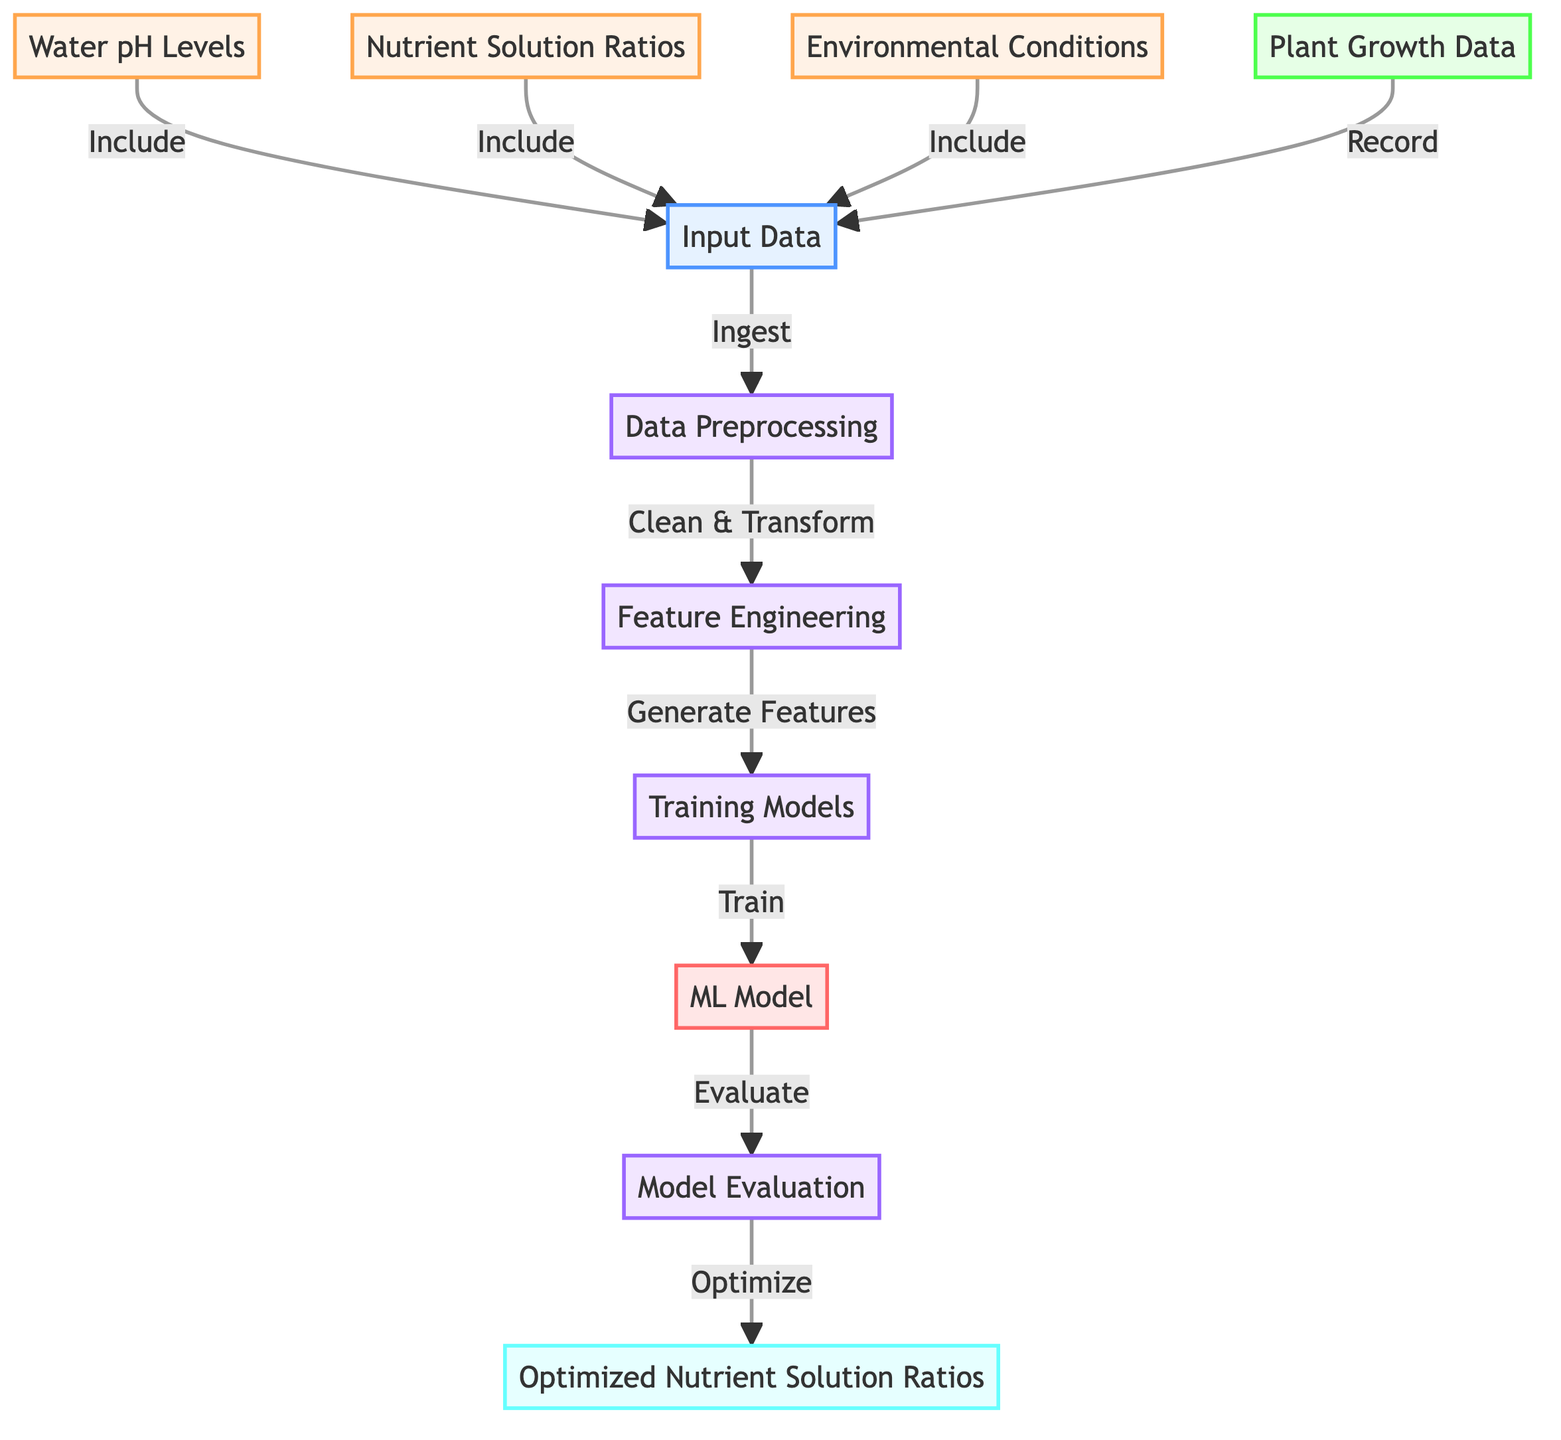What are the main factors included in the input data? According to the diagram, the main factors included in the input data are water pH levels, nutrient solution ratios, and environmental conditions. These nodes are connected with an "Include" relation to the input data node, indicating they are part of the data set being processed.
Answer: Water pH levels, nutrient solution ratios, environmental conditions How many processes are there in the diagram? The diagram contains four processes: data preprocessing, feature engineering, training models, and model evaluation. Each is distinctly marked as a process with specific nodes that reflect actions taken during the machine learning workflow.
Answer: Four What is the final output of the diagram? The final output of the diagram is the optimized nutrient solution ratios, which results from the model evaluation stage that optimizes the inputs based on the trained machine learning model. This node is clearly labeled as the output in the flowchart.
Answer: Optimized nutrient solution ratios Which node is directly connected to the feature engineering process? The node directly connected to the feature engineering process is the training models node. The arrow indicates that the feature engineering generates features which are then used to train the models, illustrating a sequential flow in the data processing.
Answer: Training models What is the relationship between the ML model and the model evaluation? The ML model is evaluated by the model evaluation process. The arrow indicates a directional flow from the ML model to the model evaluation, signifying that the evaluation step assesses the performance of the model after it has been trained.
Answer: Evaluate How does the optimized nutrient solution ratios get determined? The optimized nutrient solution ratios are determined by the model evaluation process, which optimizes the outcomes based on the trained machine learning model's evaluations. This means that the evaluation stage combines the trained model's predictions and the relevant input data to arrive at optimal ratios.
Answer: Optimize 